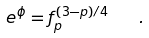Convert formula to latex. <formula><loc_0><loc_0><loc_500><loc_500>e ^ { \phi } = f _ { p } ^ { ( 3 - p ) / 4 } \quad .</formula> 